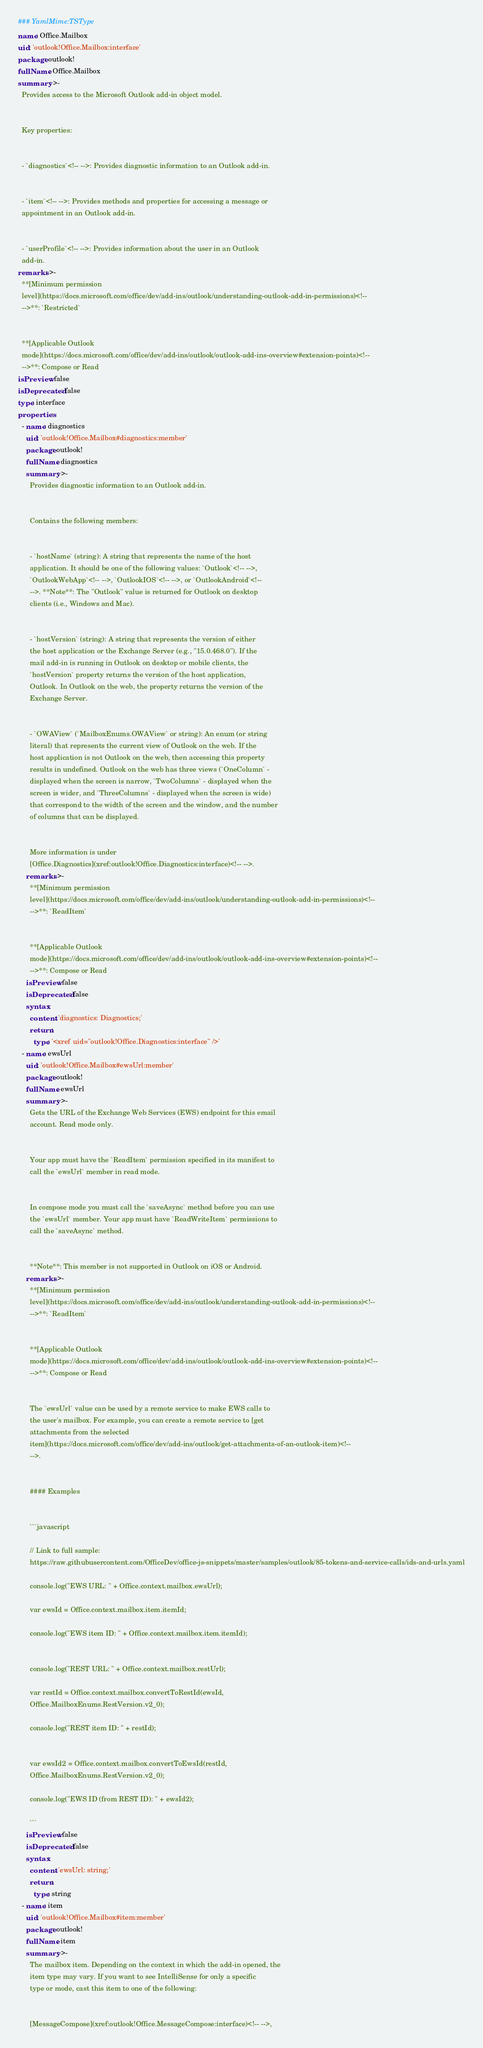<code> <loc_0><loc_0><loc_500><loc_500><_YAML_>### YamlMime:TSType
name: Office.Mailbox
uid: 'outlook!Office.Mailbox:interface'
package: outlook!
fullName: Office.Mailbox
summary: >-
  Provides access to the Microsoft Outlook add-in object model.


  Key properties:


  - `diagnostics`<!-- -->: Provides diagnostic information to an Outlook add-in.


  - `item`<!-- -->: Provides methods and properties for accessing a message or
  appointment in an Outlook add-in.


  - `userProfile`<!-- -->: Provides information about the user in an Outlook
  add-in.
remarks: >-
  **[Minimum permission
  level](https://docs.microsoft.com/office/dev/add-ins/outlook/understanding-outlook-add-in-permissions)<!--
  -->**: `Restricted`


  **[Applicable Outlook
  mode](https://docs.microsoft.com/office/dev/add-ins/outlook/outlook-add-ins-overview#extension-points)<!--
  -->**: Compose or Read
isPreview: false
isDeprecated: false
type: interface
properties:
  - name: diagnostics
    uid: 'outlook!Office.Mailbox#diagnostics:member'
    package: outlook!
    fullName: diagnostics
    summary: >-
      Provides diagnostic information to an Outlook add-in.


      Contains the following members:


      - `hostName` (string): A string that represents the name of the host
      application. It should be one of the following values: `Outlook`<!-- -->,
      `OutlookWebApp`<!-- -->, `OutlookIOS`<!-- -->, or `OutlookAndroid`<!--
      -->. **Note**: The "Outlook" value is returned for Outlook on desktop
      clients (i.e., Windows and Mac).


      - `hostVersion` (string): A string that represents the version of either
      the host application or the Exchange Server (e.g., "15.0.468.0"). If the
      mail add-in is running in Outlook on desktop or mobile clients, the
      `hostVersion` property returns the version of the host application,
      Outlook. In Outlook on the web, the property returns the version of the
      Exchange Server.


      - `OWAView` (`MailboxEnums.OWAView` or string): An enum (or string
      literal) that represents the current view of Outlook on the web. If the
      host application is not Outlook on the web, then accessing this property
      results in undefined. Outlook on the web has three views (`OneColumn` -
      displayed when the screen is narrow, `TwoColumns` - displayed when the
      screen is wider, and `ThreeColumns` - displayed when the screen is wide)
      that correspond to the width of the screen and the window, and the number
      of columns that can be displayed.


      More information is under
      [Office.Diagnostics](xref:outlook!Office.Diagnostics:interface)<!-- -->.
    remarks: >-
      **[Minimum permission
      level](https://docs.microsoft.com/office/dev/add-ins/outlook/understanding-outlook-add-in-permissions)<!--
      -->**: `ReadItem`


      **[Applicable Outlook
      mode](https://docs.microsoft.com/office/dev/add-ins/outlook/outlook-add-ins-overview#extension-points)<!--
      -->**: Compose or Read
    isPreview: false
    isDeprecated: false
    syntax:
      content: 'diagnostics: Diagnostics;'
      return:
        type: '<xref uid="outlook!Office.Diagnostics:interface" />'
  - name: ewsUrl
    uid: 'outlook!Office.Mailbox#ewsUrl:member'
    package: outlook!
    fullName: ewsUrl
    summary: >-
      Gets the URL of the Exchange Web Services (EWS) endpoint for this email
      account. Read mode only.


      Your app must have the `ReadItem` permission specified in its manifest to
      call the `ewsUrl` member in read mode.


      In compose mode you must call the `saveAsync` method before you can use
      the `ewsUrl` member. Your app must have `ReadWriteItem` permissions to
      call the `saveAsync` method.


      **Note**: This member is not supported in Outlook on iOS or Android.
    remarks: >-
      **[Minimum permission
      level](https://docs.microsoft.com/office/dev/add-ins/outlook/understanding-outlook-add-in-permissions)<!--
      -->**: `ReadItem`


      **[Applicable Outlook
      mode](https://docs.microsoft.com/office/dev/add-ins/outlook/outlook-add-ins-overview#extension-points)<!--
      -->**: Compose or Read


      The `ewsUrl` value can be used by a remote service to make EWS calls to
      the user's mailbox. For example, you can create a remote service to [get
      attachments from the selected
      item](https://docs.microsoft.com/office/dev/add-ins/outlook/get-attachments-of-an-outlook-item)<!--
      -->.


      #### Examples


      ```javascript

      // Link to full sample:
      https://raw.githubusercontent.com/OfficeDev/office-js-snippets/master/samples/outlook/85-tokens-and-service-calls/ids-and-urls.yaml

      console.log("EWS URL: " + Office.context.mailbox.ewsUrl);

      var ewsId = Office.context.mailbox.item.itemId;

      console.log("EWS item ID: " + Office.context.mailbox.item.itemId);


      console.log("REST URL: " + Office.context.mailbox.restUrl);

      var restId = Office.context.mailbox.convertToRestId(ewsId,
      Office.MailboxEnums.RestVersion.v2_0);

      console.log("REST item ID: " + restId);


      var ewsId2 = Office.context.mailbox.convertToEwsId(restId,
      Office.MailboxEnums.RestVersion.v2_0);

      console.log("EWS ID (from REST ID): " + ewsId2);

      ```
    isPreview: false
    isDeprecated: false
    syntax:
      content: 'ewsUrl: string;'
      return:
        type: string
  - name: item
    uid: 'outlook!Office.Mailbox#item:member'
    package: outlook!
    fullName: item
    summary: >-
      The mailbox item. Depending on the context in which the add-in opened, the
      item type may vary. If you want to see IntelliSense for only a specific
      type or mode, cast this item to one of the following:


      [MessageCompose](xref:outlook!Office.MessageCompose:interface)<!-- -->,</code> 